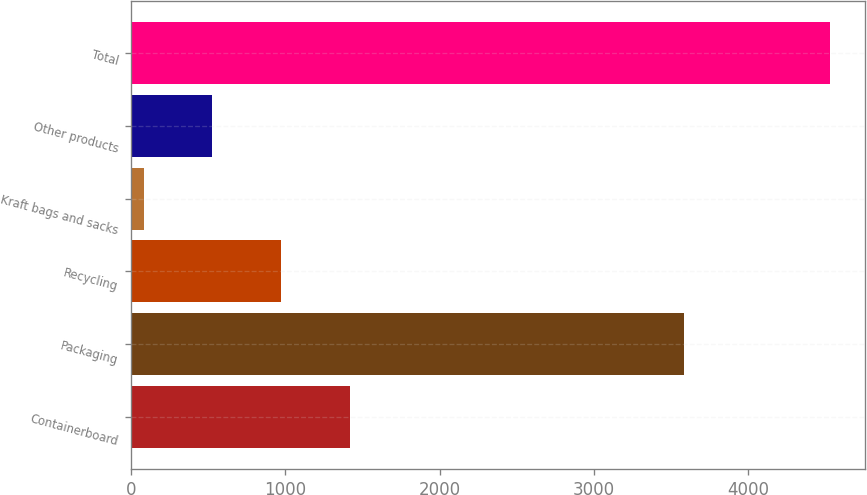Convert chart to OTSL. <chart><loc_0><loc_0><loc_500><loc_500><bar_chart><fcel>Containerboard<fcel>Packaging<fcel>Recycling<fcel>Kraft bags and sacks<fcel>Other products<fcel>Total<nl><fcel>1416.5<fcel>3584<fcel>971<fcel>80<fcel>525.5<fcel>4535<nl></chart> 